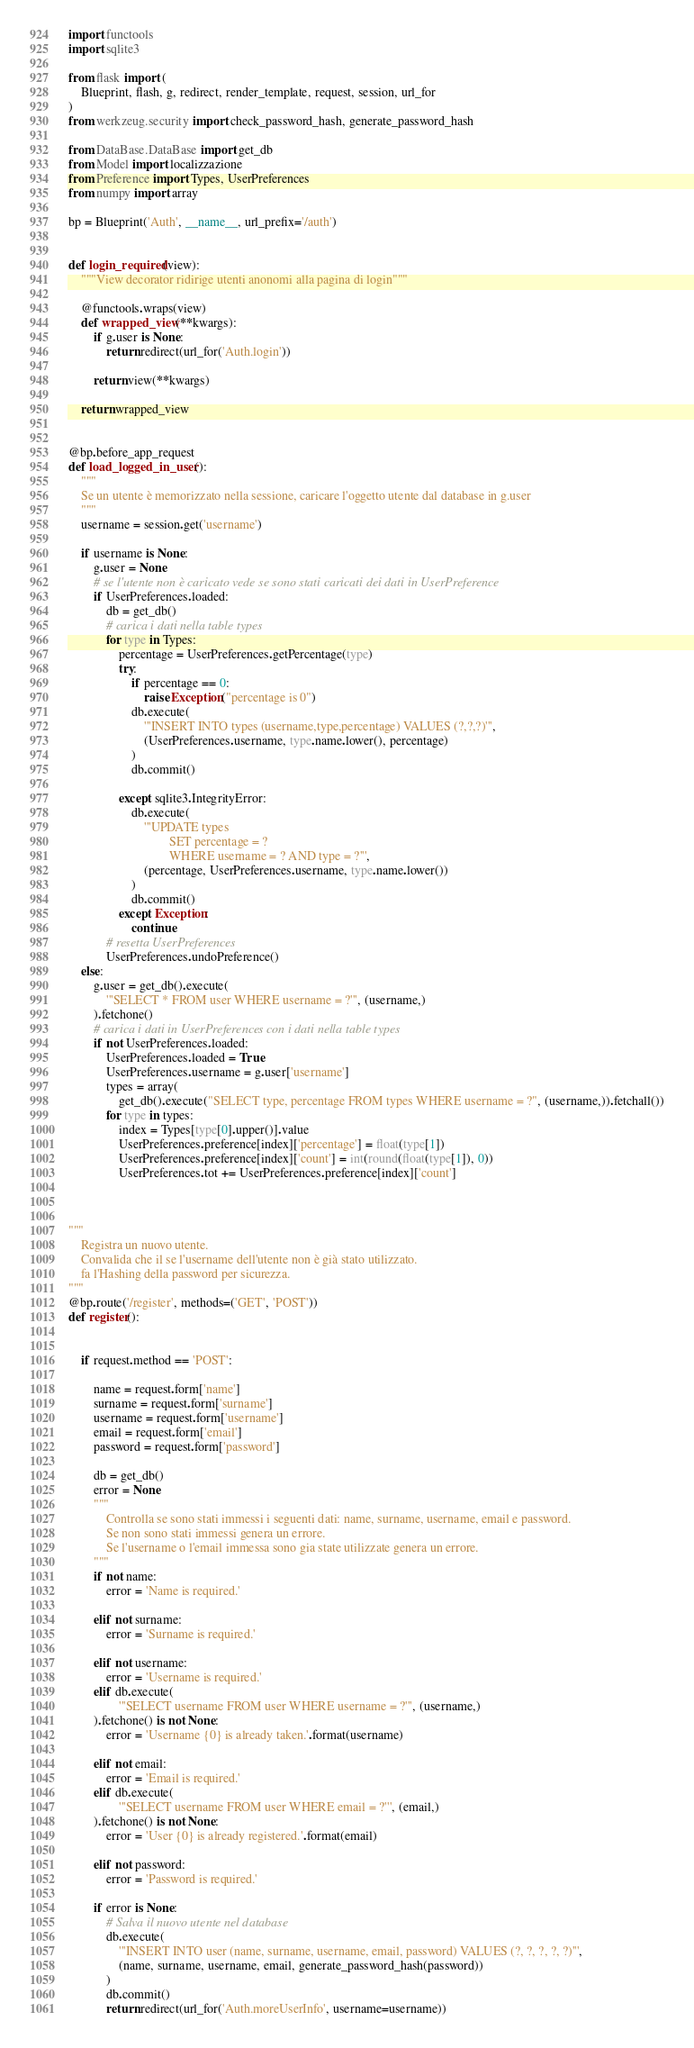Convert code to text. <code><loc_0><loc_0><loc_500><loc_500><_Python_>import functools
import sqlite3

from flask import (
    Blueprint, flash, g, redirect, render_template, request, session, url_for
)
from werkzeug.security import check_password_hash, generate_password_hash

from DataBase.DataBase import get_db
from Model import localizzazione
from Preference import Types, UserPreferences
from numpy import array

bp = Blueprint('Auth', __name__, url_prefix='/auth')


def login_required(view):
    """View decorator ridirige utenti anonomi alla pagina di login"""

    @functools.wraps(view)
    def wrapped_view(**kwargs):
        if g.user is None:
            return redirect(url_for('Auth.login'))

        return view(**kwargs)

    return wrapped_view


@bp.before_app_request
def load_logged_in_user():
    """
    Se un utente è memorizzato nella sessione, caricare l'oggetto utente dal database in g.user
    """
    username = session.get('username')

    if username is None:
        g.user = None
        # se l'utente non è caricato vede se sono stati caricati dei dati in UserPreference
        if UserPreferences.loaded:
            db = get_db()
            # carica i dati nella table types
            for type in Types:
                percentage = UserPreferences.getPercentage(type)
                try:
                    if percentage == 0:
                        raise Exception("percentage is 0")
                    db.execute(
                        '''INSERT INTO types (username,type,percentage) VALUES (?,?,?)''',
                        (UserPreferences.username, type.name.lower(), percentage)
                    )
                    db.commit()

                except sqlite3.IntegrityError:
                    db.execute(
                        '''UPDATE types
                                SET percentage = ?
                                WHERE username = ? AND type = ?''',
                        (percentage, UserPreferences.username, type.name.lower())
                    )
                    db.commit()
                except Exception:
                    continue
            # resetta UserPreferences
            UserPreferences.undoPreference()
    else:
        g.user = get_db().execute(
            '''SELECT * FROM user WHERE username = ?''', (username,)
        ).fetchone()
        # carica i dati in UserPreferences con i dati nella table types
        if not UserPreferences.loaded:
            UserPreferences.loaded = True
            UserPreferences.username = g.user['username']
            types = array(
                get_db().execute("SELECT type, percentage FROM types WHERE username = ?", (username,)).fetchall())
            for type in types:
                index = Types[type[0].upper()].value
                UserPreferences.preference[index]['percentage'] = float(type[1])
                UserPreferences.preference[index]['count'] = int(round(float(type[1]), 0))
                UserPreferences.tot += UserPreferences.preference[index]['count']



"""
    Registra un nuovo utente.
    Convalida che il se l'username dell'utente non è già stato utilizzato. 
    fa l'Hashing della password per sicurezza.
"""
@bp.route('/register', methods=('GET', 'POST'))
def register():


    if request.method == 'POST':

        name = request.form['name']
        surname = request.form['surname']
        username = request.form['username']
        email = request.form['email']
        password = request.form['password']

        db = get_db()
        error = None
        """
            Controlla se sono stati immessi i seguenti dati: name, surname, username, email e password.
            Se non sono stati immessi genera un errore.
            Se l'username o l'email immessa sono gia state utilizzate genera un errore.
        """
        if not name:
            error = 'Name is required.'

        elif not surname:
            error = 'Surname is required.'

        elif not username:
            error = 'Username is required.'
        elif db.execute(
                '''SELECT username FROM user WHERE username = ?''', (username,)
        ).fetchone() is not None:
            error = 'Username {0} is already taken.'.format(username)

        elif not email:
            error = 'Email is required.'
        elif db.execute(
                '''SELECT username FROM user WHERE email = ?''', (email,)
        ).fetchone() is not None:
            error = 'User {0} is already registered.'.format(email)

        elif not password:
            error = 'Password is required.'

        if error is None:
            # Salva il nuovo utente nel database
            db.execute(
                '''INSERT INTO user (name, surname, username, email, password) VALUES (?, ?, ?, ?, ?)''',
                (name, surname, username, email, generate_password_hash(password))
            )
            db.commit()
            return redirect(url_for('Auth.moreUserInfo', username=username))
</code> 